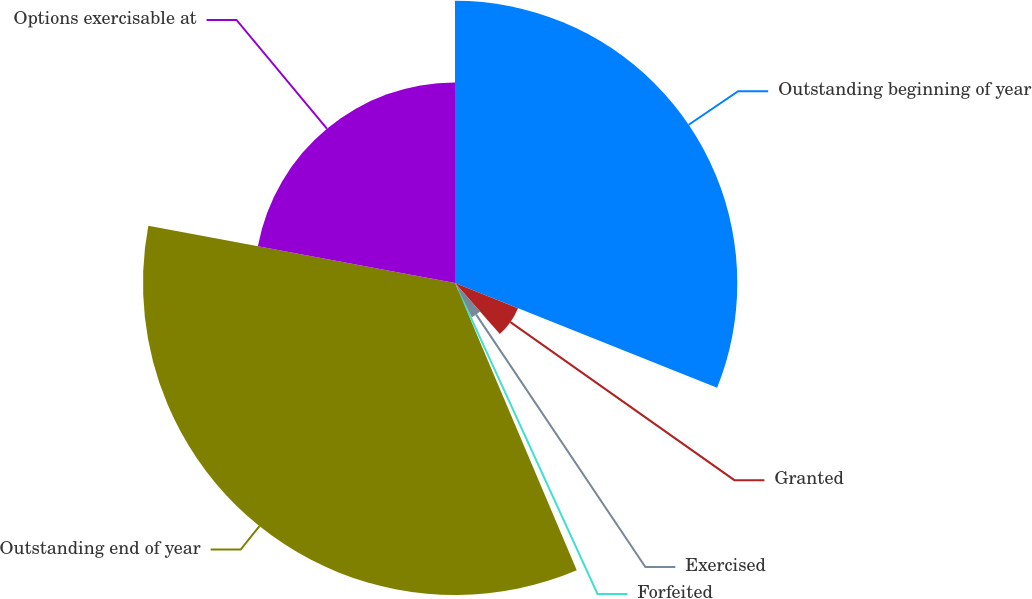Convert chart to OTSL. <chart><loc_0><loc_0><loc_500><loc_500><pie_chart><fcel>Outstanding beginning of year<fcel>Granted<fcel>Exercised<fcel>Forfeited<fcel>Outstanding end of year<fcel>Options exercisable at<nl><fcel>31.05%<fcel>7.46%<fcel>4.19%<fcel>0.92%<fcel>34.32%<fcel>22.06%<nl></chart> 